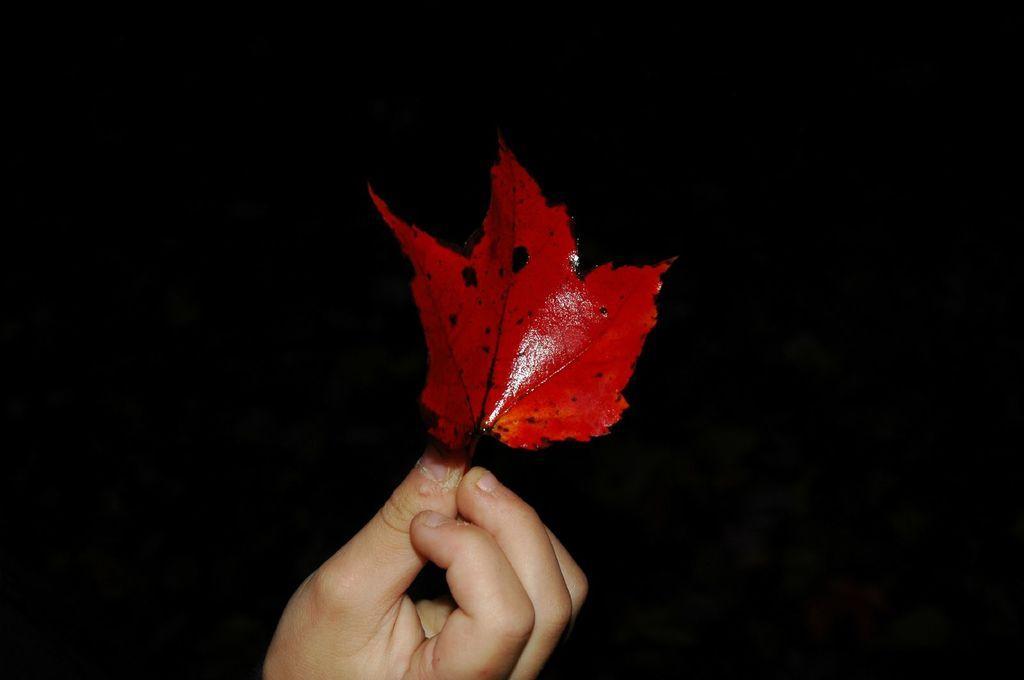Describe this image in one or two sentences. In this image there is a person holding a leaf which is red in colour. 